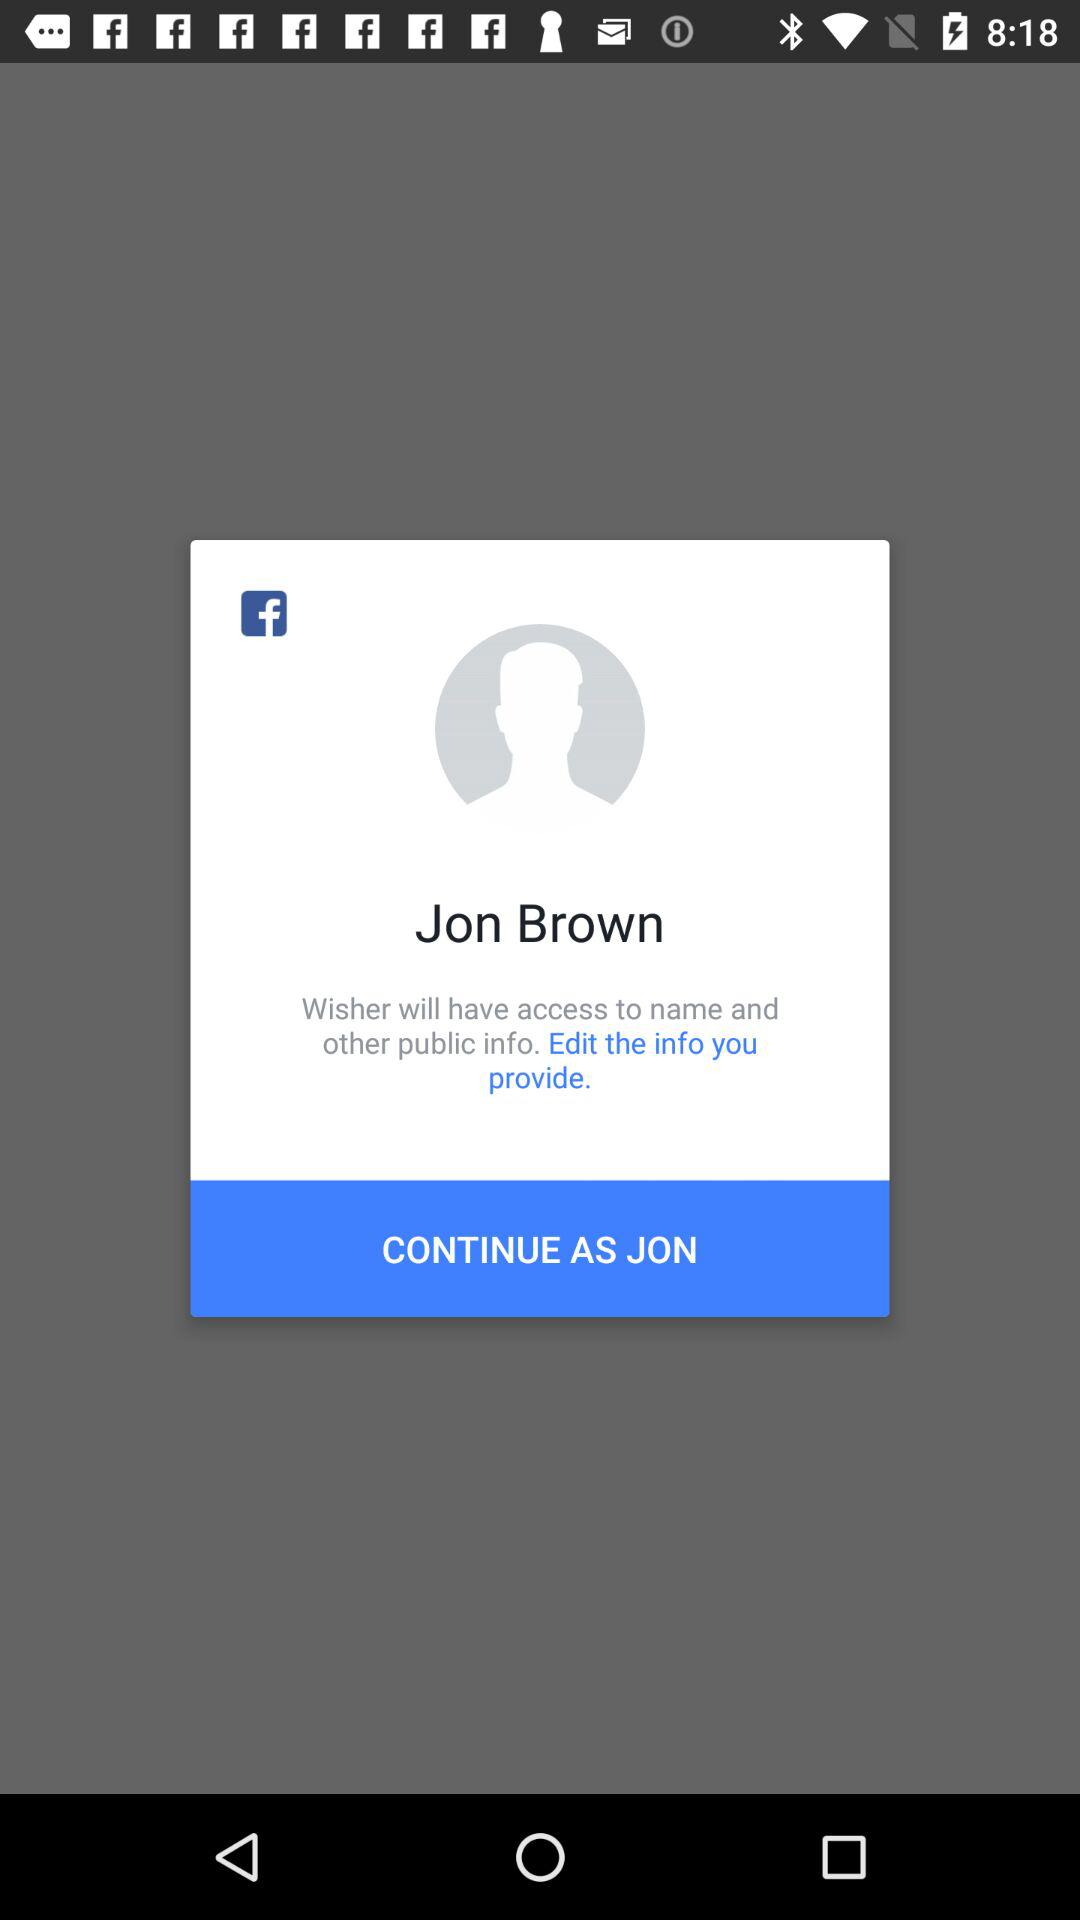What is the profile name? The profile name is Jon Brown. 